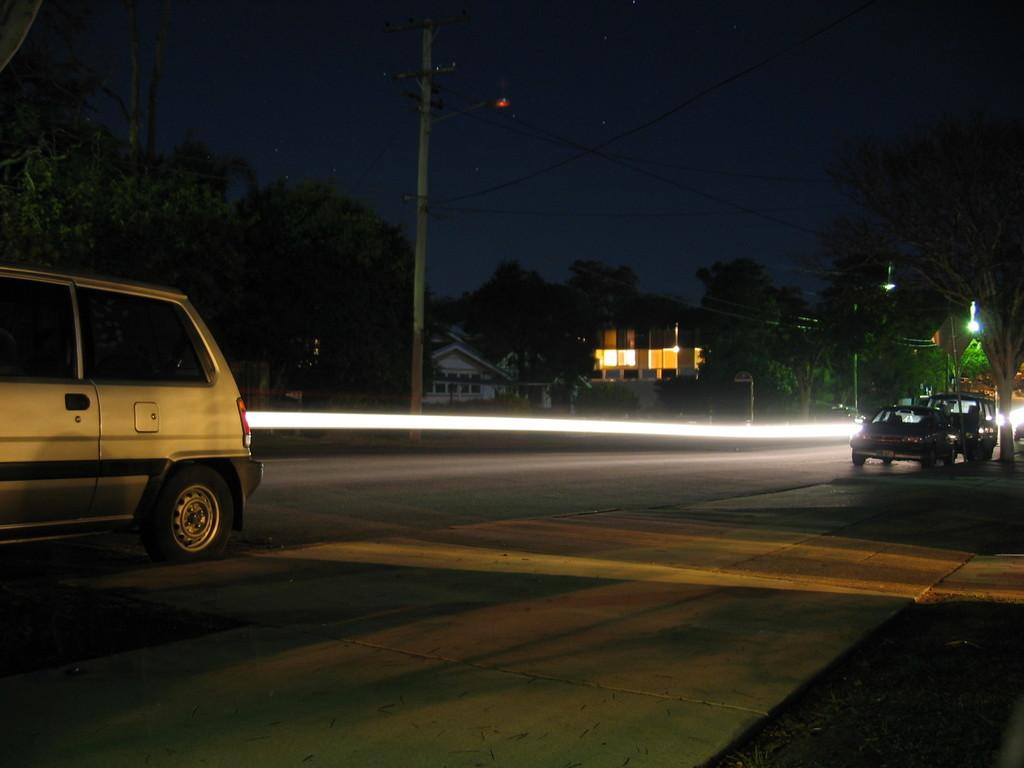What is the main feature of the image? There is a road in the image. What is happening on the road? Cars are visible on the road. What can be seen in the background of the image? There are trees and a building in the background of the image. What is visible at the top of the image? The sky is visible at the top of the image. What type of nerve can be seen in the image? There is no nerve present in the image; it features a road, cars, trees, a building, and the sky. 